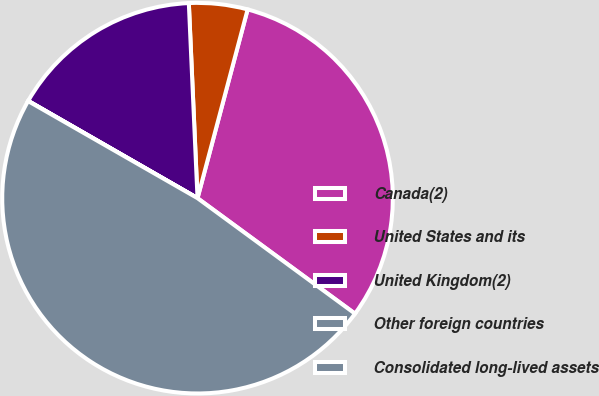<chart> <loc_0><loc_0><loc_500><loc_500><pie_chart><fcel>Canada(2)<fcel>United States and its<fcel>United Kingdom(2)<fcel>Other foreign countries<fcel>Consolidated long-lived assets<nl><fcel>30.94%<fcel>4.84%<fcel>15.99%<fcel>0.02%<fcel>48.21%<nl></chart> 